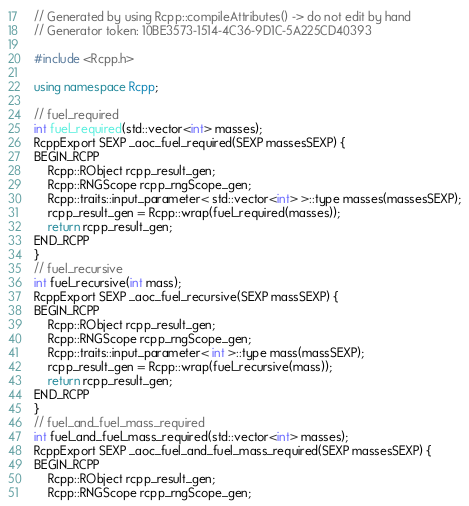Convert code to text. <code><loc_0><loc_0><loc_500><loc_500><_C++_>// Generated by using Rcpp::compileAttributes() -> do not edit by hand
// Generator token: 10BE3573-1514-4C36-9D1C-5A225CD40393

#include <Rcpp.h>

using namespace Rcpp;

// fuel_required
int fuel_required(std::vector<int> masses);
RcppExport SEXP _aoc_fuel_required(SEXP massesSEXP) {
BEGIN_RCPP
    Rcpp::RObject rcpp_result_gen;
    Rcpp::RNGScope rcpp_rngScope_gen;
    Rcpp::traits::input_parameter< std::vector<int> >::type masses(massesSEXP);
    rcpp_result_gen = Rcpp::wrap(fuel_required(masses));
    return rcpp_result_gen;
END_RCPP
}
// fuel_recursive
int fuel_recursive(int mass);
RcppExport SEXP _aoc_fuel_recursive(SEXP massSEXP) {
BEGIN_RCPP
    Rcpp::RObject rcpp_result_gen;
    Rcpp::RNGScope rcpp_rngScope_gen;
    Rcpp::traits::input_parameter< int >::type mass(massSEXP);
    rcpp_result_gen = Rcpp::wrap(fuel_recursive(mass));
    return rcpp_result_gen;
END_RCPP
}
// fuel_and_fuel_mass_required
int fuel_and_fuel_mass_required(std::vector<int> masses);
RcppExport SEXP _aoc_fuel_and_fuel_mass_required(SEXP massesSEXP) {
BEGIN_RCPP
    Rcpp::RObject rcpp_result_gen;
    Rcpp::RNGScope rcpp_rngScope_gen;</code> 